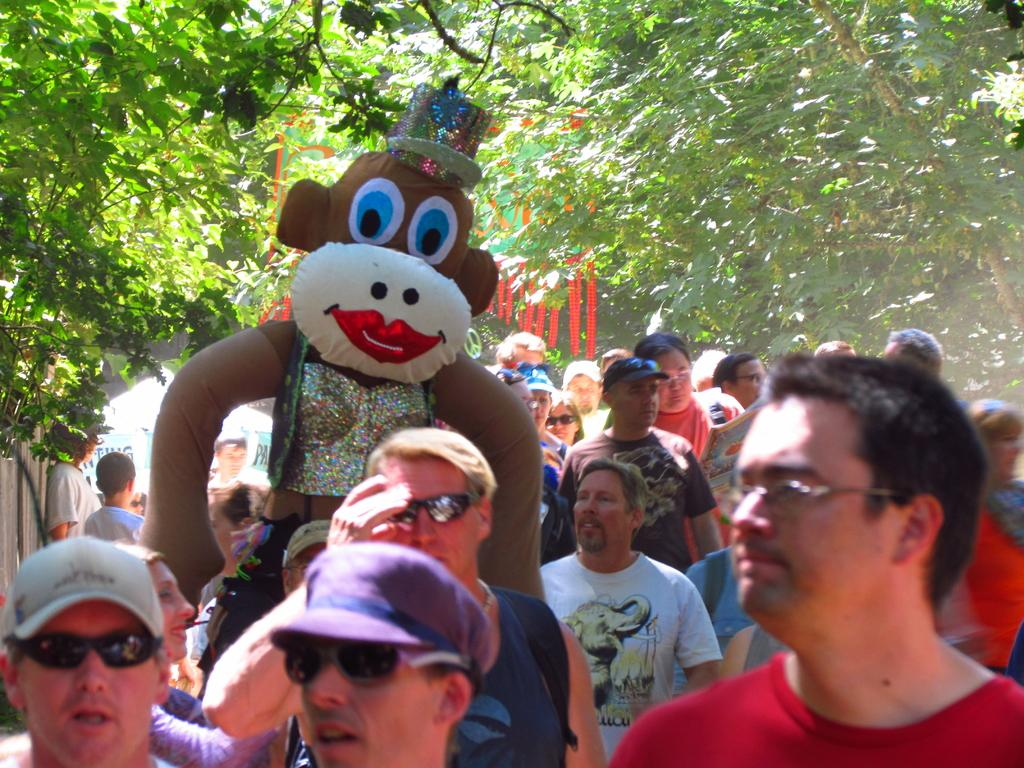What can be seen at the bottom of the image? There are persons at the bottom of the image. What are the persons wearing? The persons are wearing different color dresses. What is one person holding? One person is holding a doll. What is visible in the background of the image? There are trees in the background of the image. What type of authority figure can be seen in the image? There is no authority figure present in the image. What material is the brass used for in the image? There is no brass present in the image. 